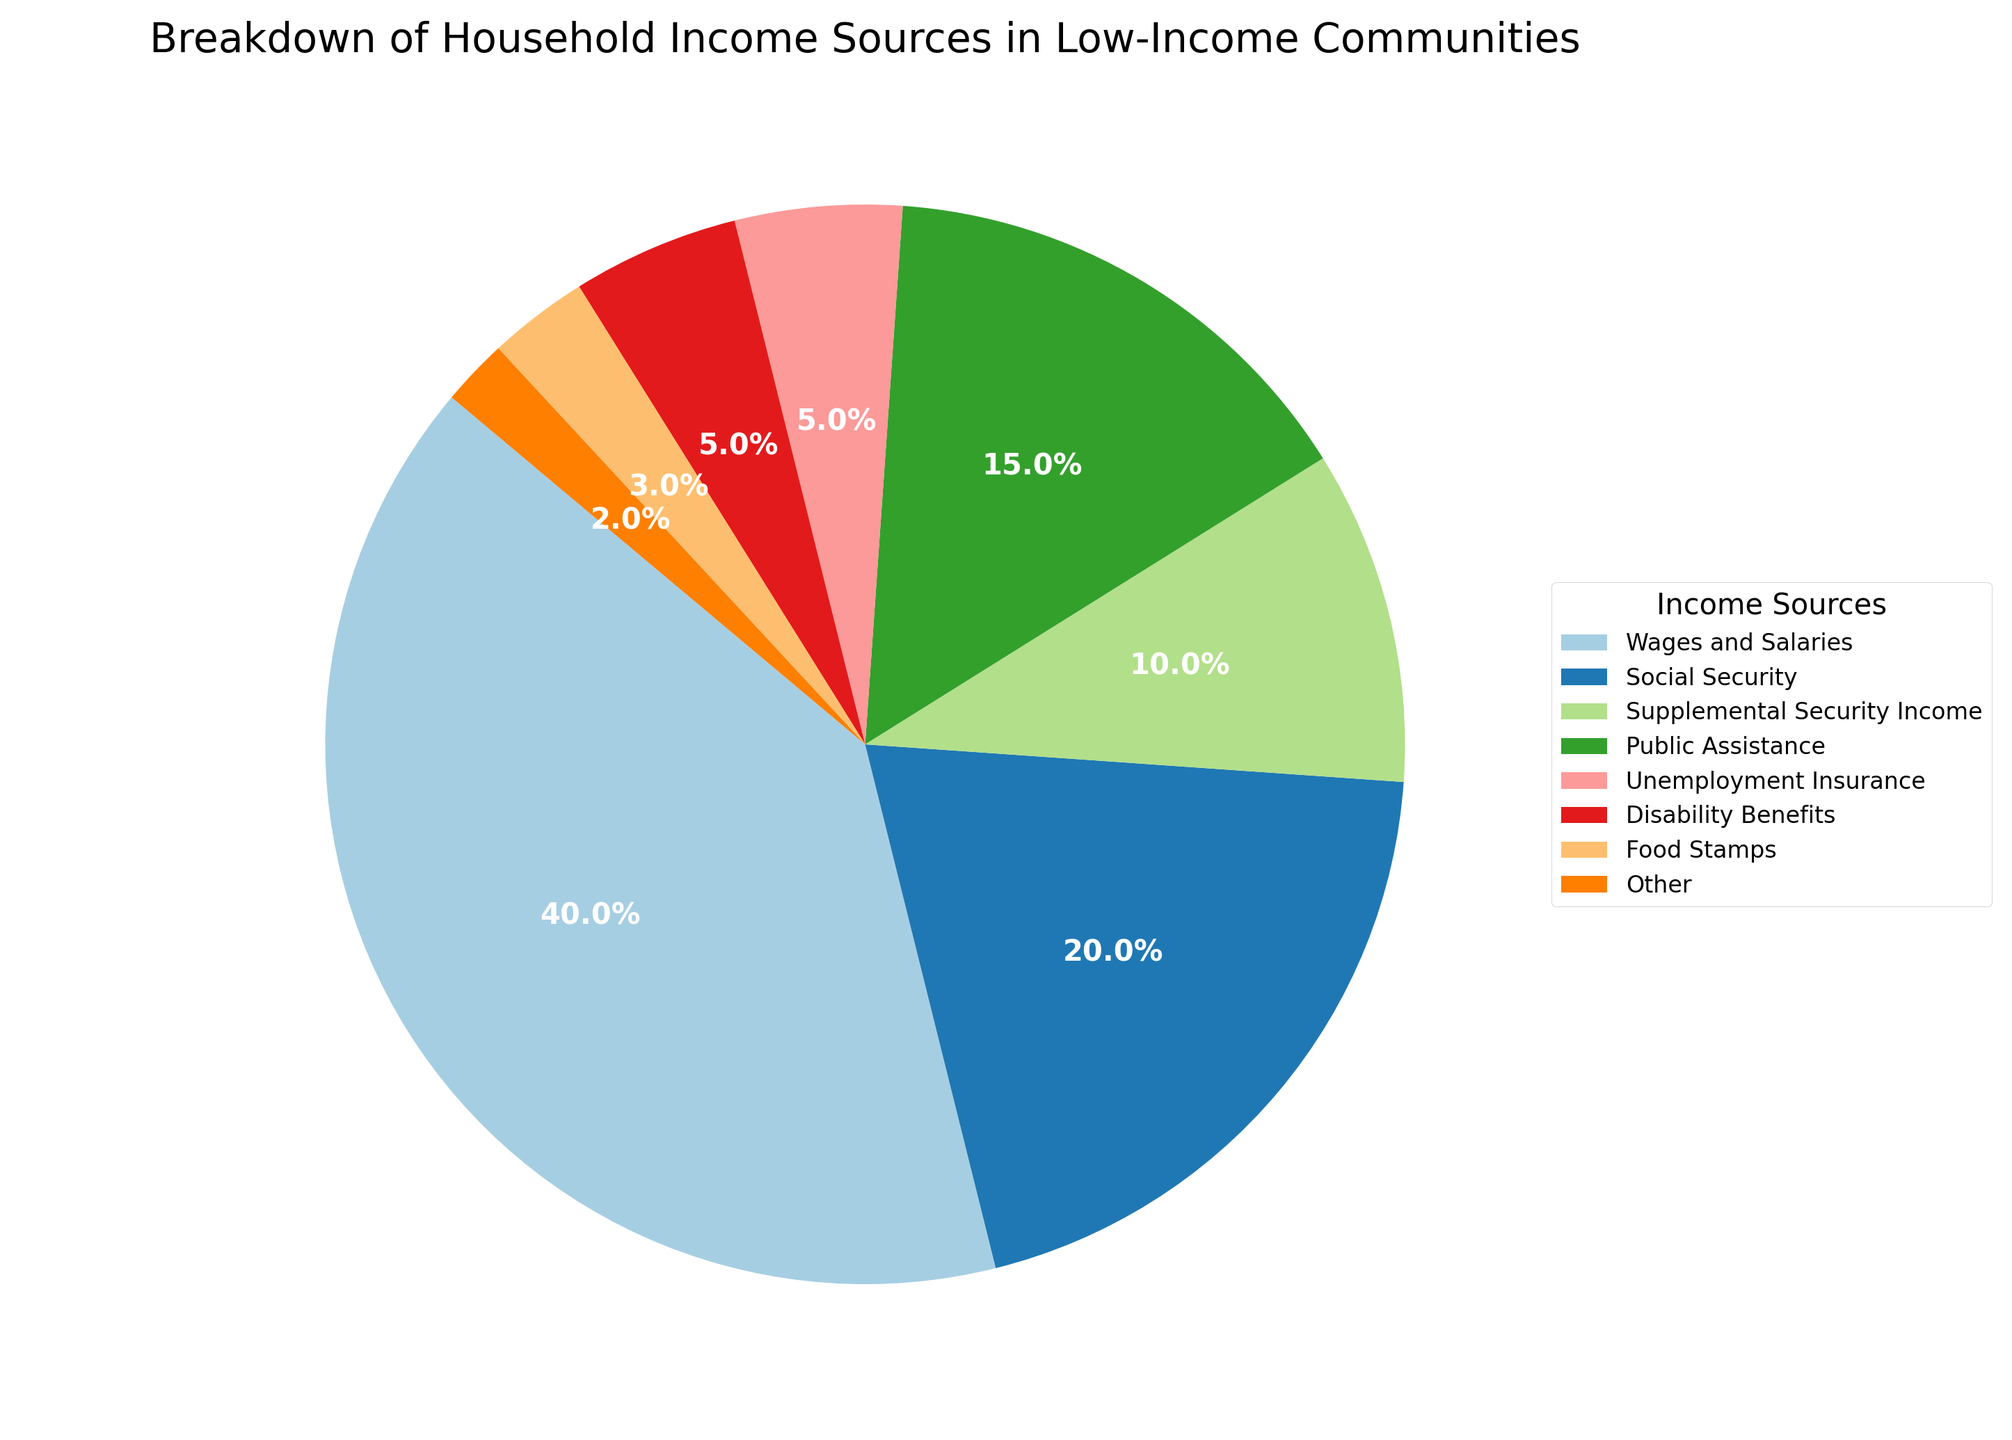What percentage of household income comes from government assistance programs (Social Security, Supplemental Security Income, Public Assistance, Unemployment Insurance, Disability Benefits, and Food Stamps)? Add the percentages of income sources from government assistance: Social Security (20%), Supplemental Security Income (10%), Public Assistance (15%), Unemployment Insurance (5%), Disability Benefits (5%), and Food Stamps (3%). Thus, 20% + 10% + 15% + 5% + 5% + 3% = 58%.
Answer: 58% Which category contributes the most to household income? Look for the category with the largest percentage in the pie chart. Wages and Salaries make up the largest portion at 40%.
Answer: Wages and Salaries Is the combined income from Public Assistance and Supplemental Security Income larger than the income from Social Security? Compare the sums: Public Assistance (15%) + Supplemental Security Income (10%) = 25%, which is larger than Social Security’s 20%.
Answer: Yes What is the difference in percentage points between the highest and lowest income sources? Subtract the percentage of the lowest income source (Other: 2%) from the highest income source (Wages and Salaries: 40%). Thus, 40% - 2% = 38%.
Answer: 38% Are Food Stamps a more significant income source than Other sources? Compare the percentages of Food Stamps (3%) and Other sources (2%). Food Stamps are higher.
Answer: Yes Which two sources, when combined, contribute exactly 25% to household income? Check the combinations: Unemployment Insurance (5%) + Public Assistance (15%) + Other (2%) + Disability Benefits (5%) = 12% + 10% + 15% + 3% = 25%. Thus, Supplemental Security Income (10%) and Public Assistance (15%) together make 25%.
Answer: Supplemental Security Income and Public Assistance How does Public Assistance compare to Disability Benefits in terms of percentage? Compare the percentages in the pie chart: Public Assistance is at 15%, while Disability Benefits are at 5%. Public Assistance is higher.
Answer: Public Assistance is higher What's the total percentage for income sources that each contribute less than 10%? Sum the percentages of income sources less than 10%: Supplemental Security Income (10%) is excluded, so count Unemployment Insurance (5%), Disability Benefits (5%), Food Stamps (3%), and Other (2%). Thus, 5% + 5% + 3% + 2% = 15%.
Answer: 15% Would the sum of percentages from Wages and Salaries and Unemployment Insurance be more than half of the total household income? Add the percentages of Wages and Salaries (40%) and Unemployment Insurance (5%): 40% + 5% = 45%, which is less than 50%.
Answer: No 